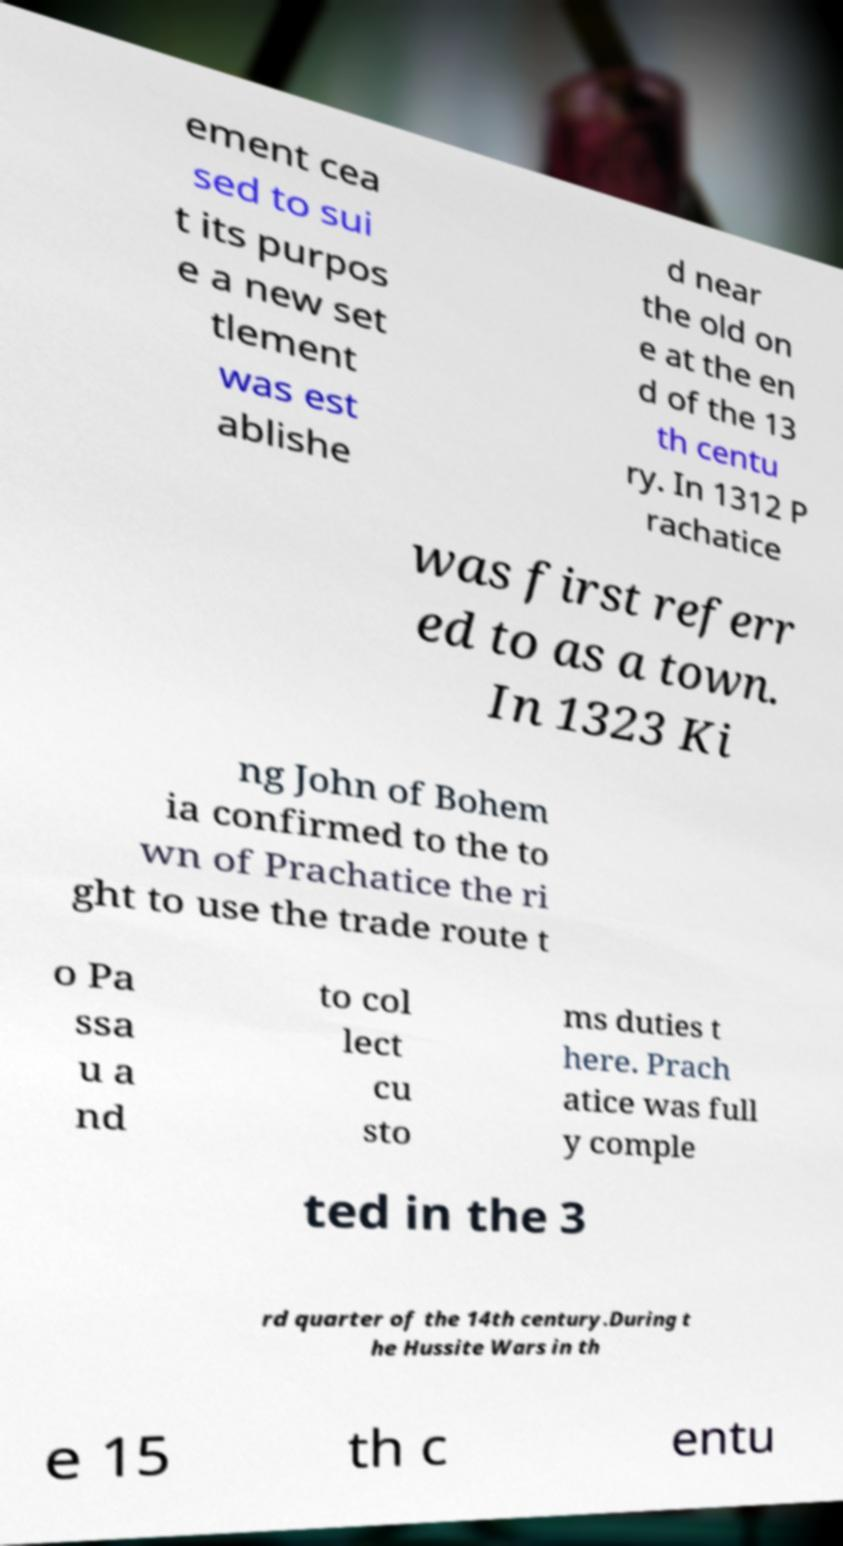For documentation purposes, I need the text within this image transcribed. Could you provide that? ement cea sed to sui t its purpos e a new set tlement was est ablishe d near the old on e at the en d of the 13 th centu ry. In 1312 P rachatice was first referr ed to as a town. In 1323 Ki ng John of Bohem ia confirmed to the to wn of Prachatice the ri ght to use the trade route t o Pa ssa u a nd to col lect cu sto ms duties t here. Prach atice was full y comple ted in the 3 rd quarter of the 14th century.During t he Hussite Wars in th e 15 th c entu 